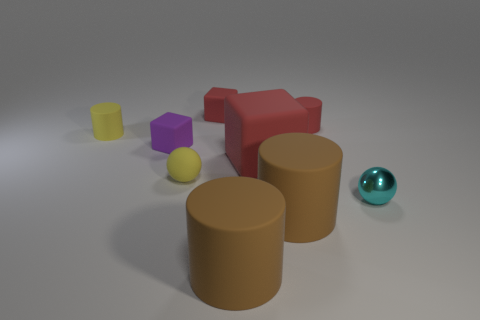Subtract all red matte cylinders. How many cylinders are left? 3 Subtract all red blocks. How many blocks are left? 1 Subtract all balls. How many objects are left? 7 Add 1 tiny yellow rubber cylinders. How many objects exist? 10 Subtract 0 blue blocks. How many objects are left? 9 Subtract 1 balls. How many balls are left? 1 Subtract all green cubes. Subtract all brown spheres. How many cubes are left? 3 Subtract all purple cubes. How many brown cylinders are left? 2 Subtract all shiny cylinders. Subtract all large matte cubes. How many objects are left? 8 Add 6 metallic balls. How many metallic balls are left? 7 